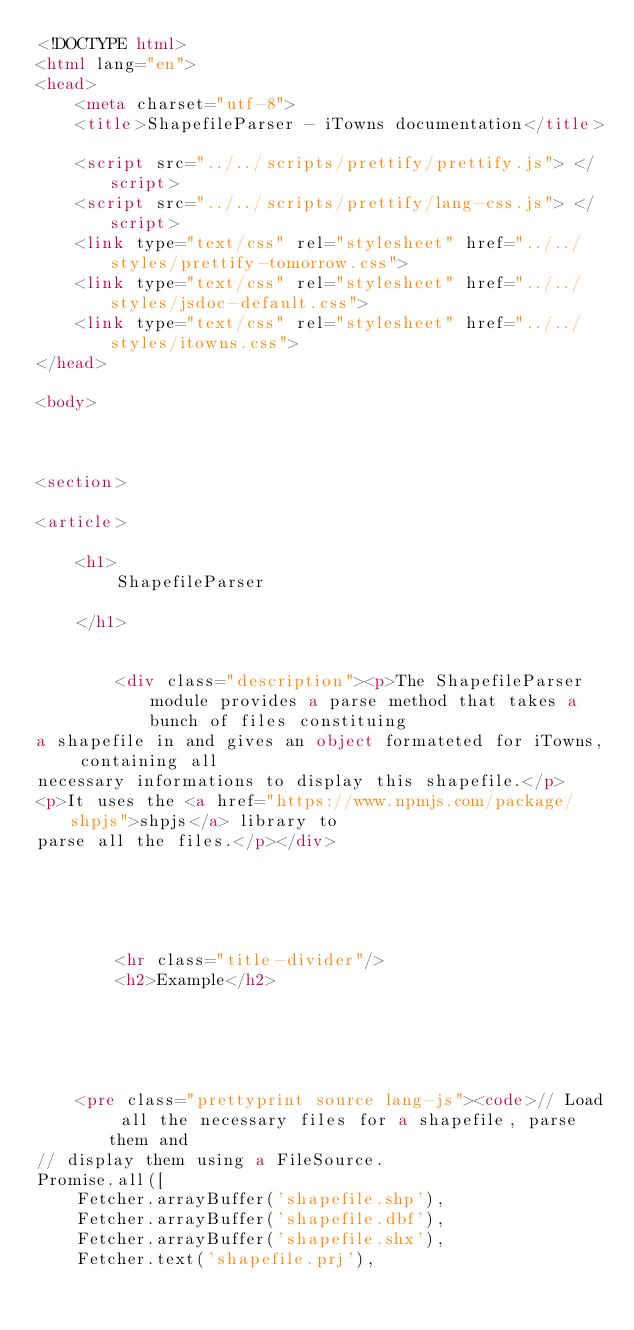Convert code to text. <code><loc_0><loc_0><loc_500><loc_500><_HTML_><!DOCTYPE html>
<html lang="en">
<head>
    <meta charset="utf-8">
    <title>ShapefileParser - iTowns documentation</title>

    <script src="../../scripts/prettify/prettify.js"> </script>
    <script src="../../scripts/prettify/lang-css.js"> </script>
    <link type="text/css" rel="stylesheet" href="../../styles/prettify-tomorrow.css">
    <link type="text/css" rel="stylesheet" href="../../styles/jsdoc-default.css">
    <link type="text/css" rel="stylesheet" href="../../styles/itowns.css">
</head>

<body>



<section>

<article>

    <h1>
        ShapefileParser
        
    </h1>

    
        <div class="description"><p>The ShapefileParser module provides a parse method that takes a bunch of files constituing
a shapefile in and gives an object formateted for iTowns, containing all
necessary informations to display this shapefile.</p>
<p>It uses the <a href="https://www.npmjs.com/package/shpjs">shpjs</a> library to
parse all the files.</p></div>
    

    

    
        <hr class="title-divider"/>
        <h2>Example</h2>
        


    

    <pre class="prettyprint source lang-js"><code>// Load all the necessary files for a shapefile, parse them and
// display them using a FileSource.
Promise.all([
    Fetcher.arrayBuffer('shapefile.shp'),
    Fetcher.arrayBuffer('shapefile.dbf'),
    Fetcher.arrayBuffer('shapefile.shx'),
    Fetcher.text('shapefile.prj'),</code> 